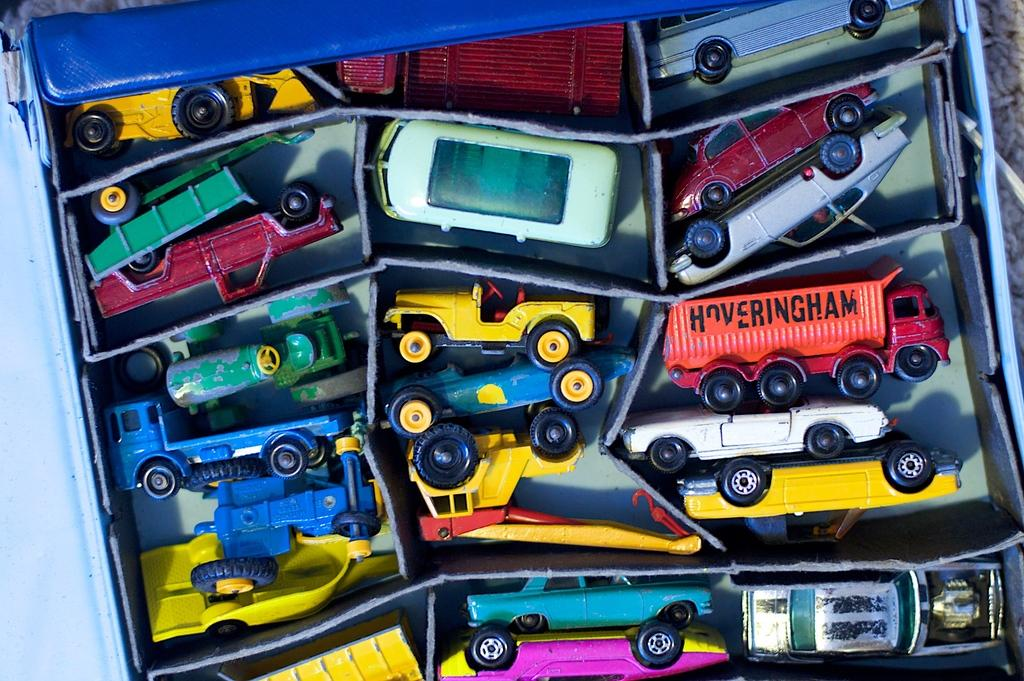What type of surface is visible in the image? There is a white, cold surface in the image. What is placed on the surface? There is a box on the surface. What is inside the box? The box contains toy vehicles. What colors are the toy vehicles? The toy vehicles are blue, yellow, black, green, pink, and red in color. What crime is being committed in the image? There is no crime being committed in the image; it features a box of toy vehicles on a white, cold surface. How does the image show respect for the environment? The image does not show respect for the environment, as it only depicts a box of toy vehicles on a white, cold surface. 